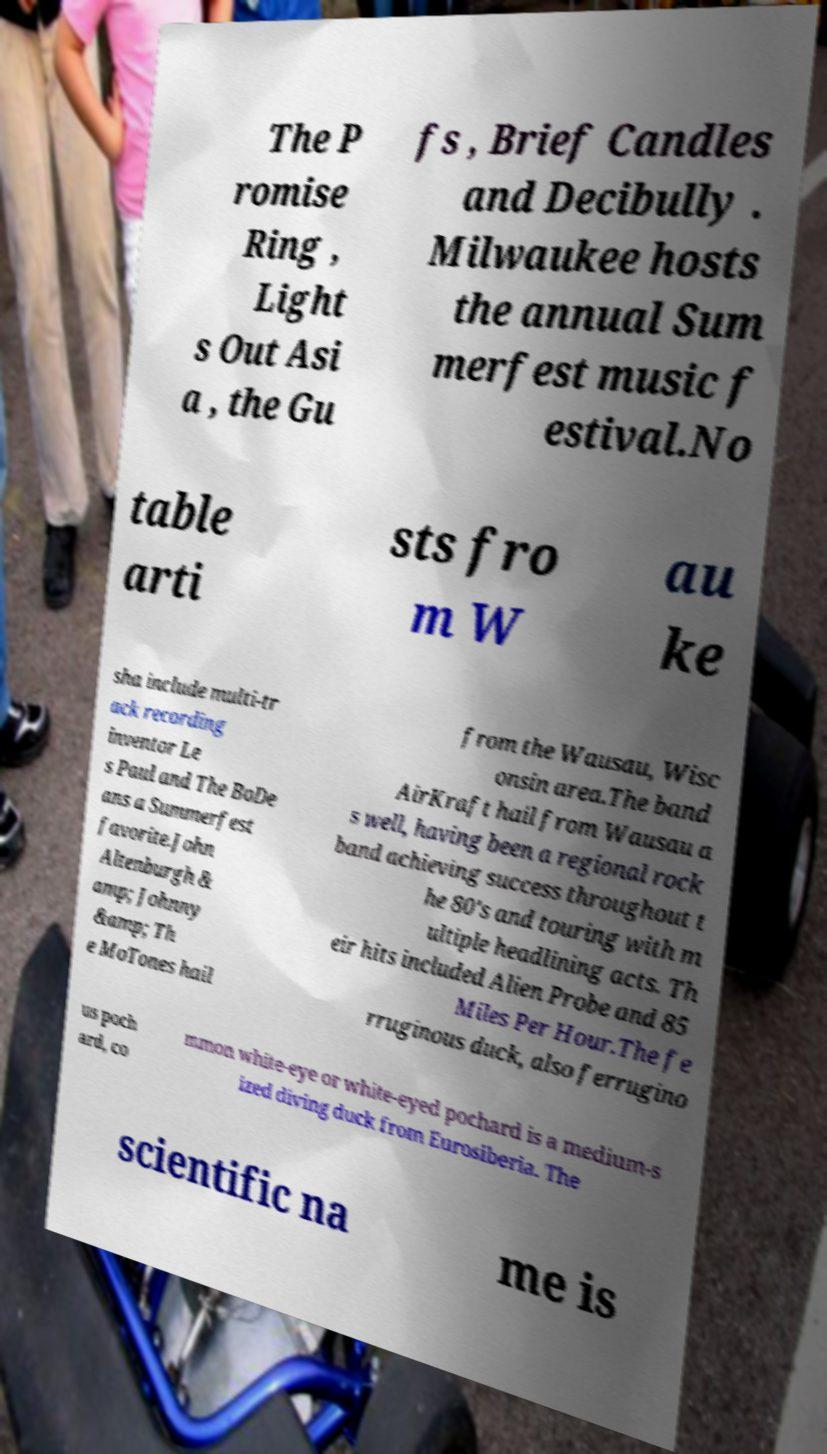Please read and relay the text visible in this image. What does it say? The P romise Ring , Light s Out Asi a , the Gu fs , Brief Candles and Decibully . Milwaukee hosts the annual Sum merfest music f estival.No table arti sts fro m W au ke sha include multi-tr ack recording inventor Le s Paul and The BoDe ans a Summerfest favorite.John Altenburgh & amp; Johnny &amp; Th e MoTones hail from the Wausau, Wisc onsin area.The band AirKraft hail from Wausau a s well, having been a regional rock band achieving success throughout t he 80's and touring with m ultiple headlining acts. Th eir hits included Alien Probe and 85 Miles Per Hour.The fe rruginous duck, also ferrugino us poch ard, co mmon white-eye or white-eyed pochard is a medium-s ized diving duck from Eurosiberia. The scientific na me is 